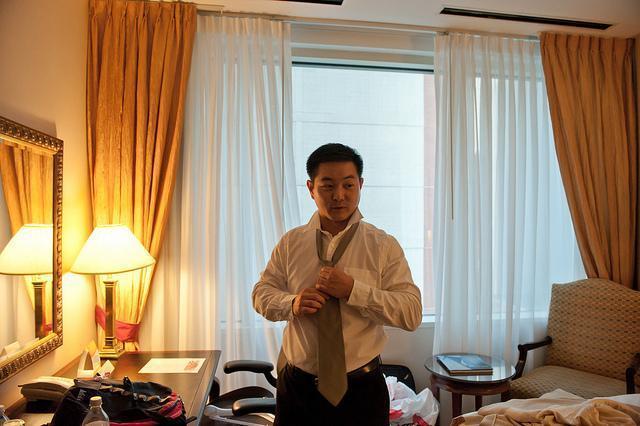How many chairs can be seen?
Give a very brief answer. 2. How many backpacks are there?
Give a very brief answer. 1. How many donuts have blue color cream?
Give a very brief answer. 0. 